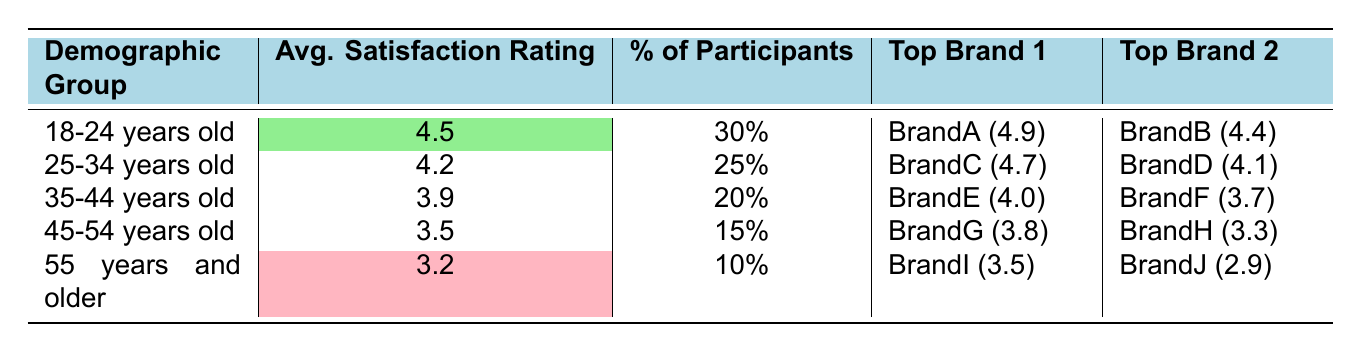What is the average satisfaction rating for the 18-24 age group? The table states that the average satisfaction rating for the 18-24 years old demographic group is 4.5.
Answer: 4.5 Which demographic group has the highest percentage of participants? According to the table, the 18-24 years old demographic group has the highest percentage of participants at 30%.
Answer: 18-24 years old What is the satisfaction score of the top brand for the 55 years and older demographic group? The table lists BrandI as the top brand for the 55 years and older group with a satisfaction score of 3.5.
Answer: 3.5 Is the average satisfaction rating for the 45-54 age group higher than that for the 35-44 age group? The average satisfaction rating for the 45-54 age group is 3.5, while for the 35-44 age group it is 3.9. Therefore, 3.5 is not higher than 3.9, making the statement false.
Answer: No What is the difference in the average satisfaction ratings between the 25-34 years old and the 45-54 years old demographics? The average satisfaction rating for the 25-34 age group is 4.2 and for the 45-54 age group is 3.5. The difference is calculated as 4.2 - 3.5 = 0.7.
Answer: 0.7 Which age group has the lowest average satisfaction rating? The table shows that the 55 years and older age group has the lowest average satisfaction rating of 3.2.
Answer: 55 years and older What are the two top brands for the 35-44 years old demographic group? The top brands listed for the 35-44 years old demographic group are BrandE with a satisfaction score of 4.0 and BrandF with a satisfaction score of 3.7.
Answer: BrandE and BrandF If we combine the percentages of participants from the 25-34 years old and 35-44 years old groups, what is the total percentage? The percentage of participants from the 25-34 years old group is 25% and from the 35-44 years old group is 20%. Adding these percentages together gives 25% + 20% = 45%.
Answer: 45% Is the satisfaction score of BrandJ lower than that of BrandG? The satisfaction score for BrandJ is 2.9 and for BrandG is 3.8. Since 2.9 is less than 3.8, the answer is true.
Answer: Yes What is the average satisfaction rating for all demographic groups combined? Adding the average satisfaction ratings: 4.5 + 4.2 + 3.9 + 3.5 + 3.2 = 19.3. Dividing by the number of groups (5) gives an average of 19.3 / 5 = 3.86.
Answer: 3.86 